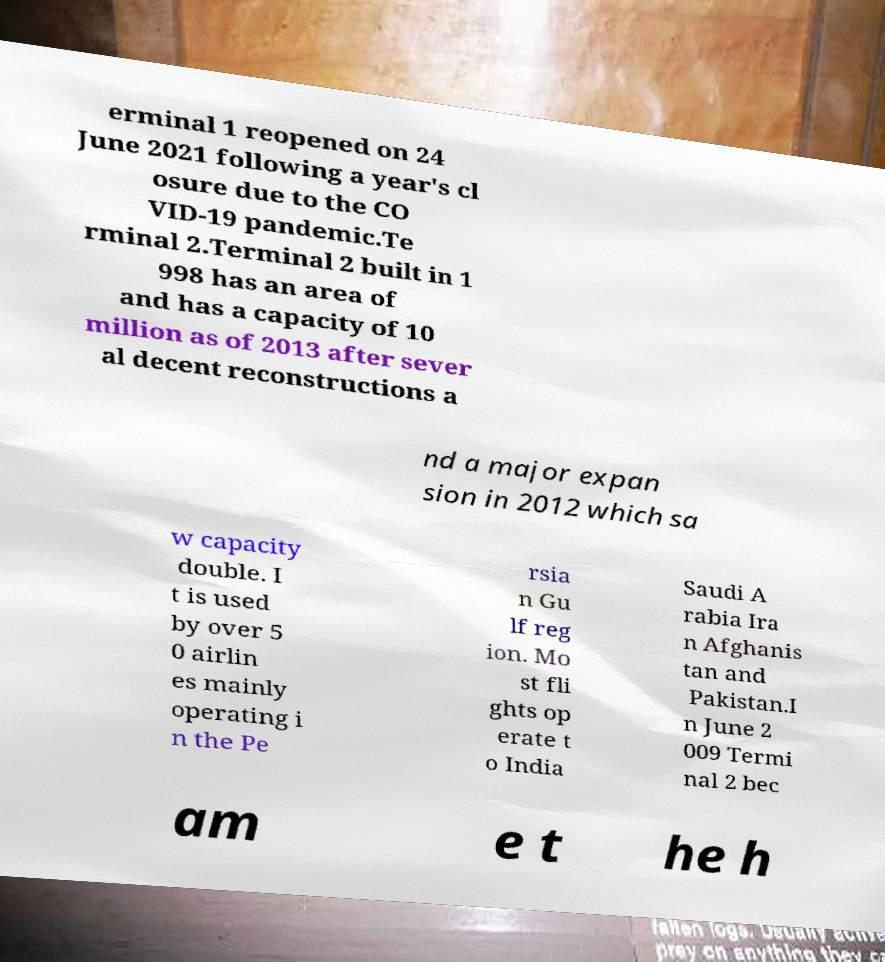Could you assist in decoding the text presented in this image and type it out clearly? erminal 1 reopened on 24 June 2021 following a year's cl osure due to the CO VID-19 pandemic.Te rminal 2.Terminal 2 built in 1 998 has an area of and has a capacity of 10 million as of 2013 after sever al decent reconstructions a nd a major expan sion in 2012 which sa w capacity double. I t is used by over 5 0 airlin es mainly operating i n the Pe rsia n Gu lf reg ion. Mo st fli ghts op erate t o India Saudi A rabia Ira n Afghanis tan and Pakistan.I n June 2 009 Termi nal 2 bec am e t he h 